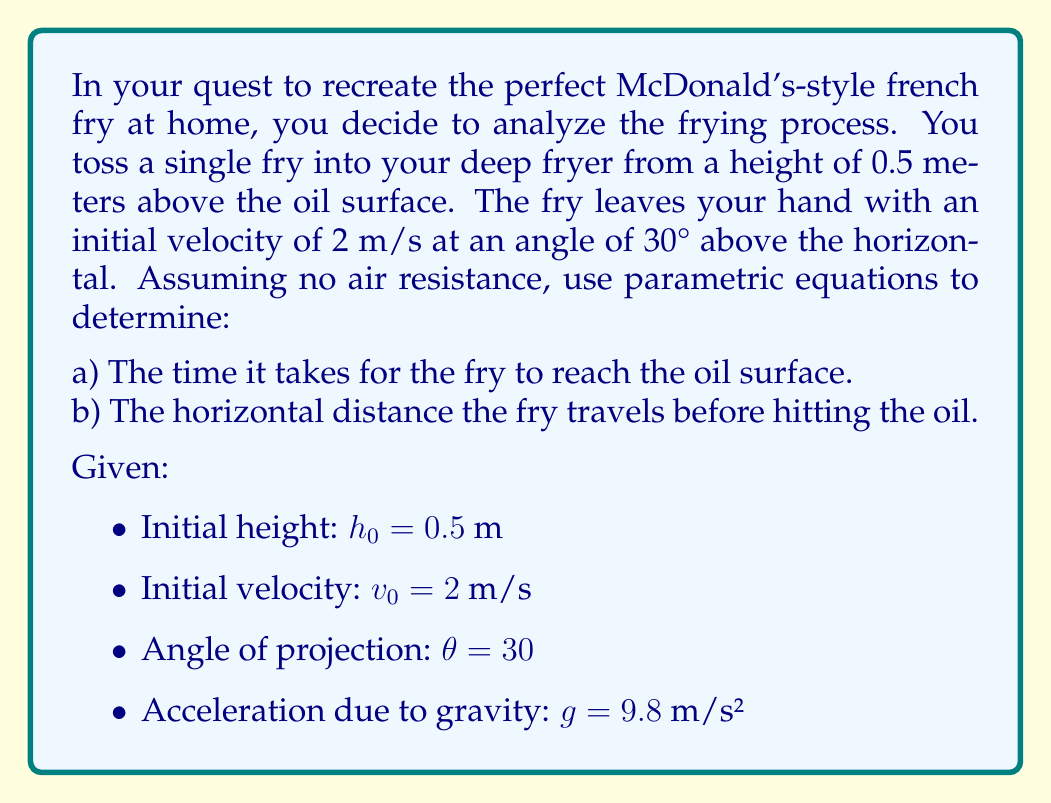Could you help me with this problem? Let's approach this problem step by step using parametric equations:

1) First, let's define our parametric equations:
   
   $x(t) = v_0 \cos(\theta) t$
   $y(t) = h_0 + v_0 \sin(\theta) t - \frac{1}{2}gt^2$

2) We need to find the components of the initial velocity:
   
   $v_{0x} = v_0 \cos(\theta) = 2 \cos(30°) = 2 \cdot \frac{\sqrt{3}}{2} = \sqrt{3}$ m/s
   $v_{0y} = v_0 \sin(\theta) = 2 \sin(30°) = 2 \cdot \frac{1}{2} = 1$ m/s

3) Now our equations become:
   
   $x(t) = \sqrt{3}t$
   $y(t) = 0.5 + t - 4.9t^2$

4) To find the time when the fry hits the oil, we need to solve $y(t) = 0$:
   
   $0 = 0.5 + t - 4.9t^2$
   $4.9t^2 - t - 0.5 = 0$

   This is a quadratic equation. We can solve it using the quadratic formula:
   
   $t = \frac{-b \pm \sqrt{b^2 - 4ac}}{2a}$

   Where $a = 4.9$, $b = -1$, and $c = -0.5$

   $t = \frac{1 \pm \sqrt{1 - 4(4.9)(-0.5)}}{2(4.9)} = \frac{1 \pm \sqrt{10.8}}{9.8}$

   We take the positive root as we're interested in the future time:
   
   $t = \frac{1 + \sqrt{10.8}}{9.8} \approx 0.4382$ seconds

5) To find the horizontal distance, we plug this time into our $x(t)$ equation:
   
   $x = \sqrt{3} \cdot 0.4382 \approx 0.7590$ meters
Answer: a) The time it takes for the fry to reach the oil surface is approximately 0.4382 seconds.
b) The horizontal distance the fry travels before hitting the oil is approximately 0.7590 meters. 